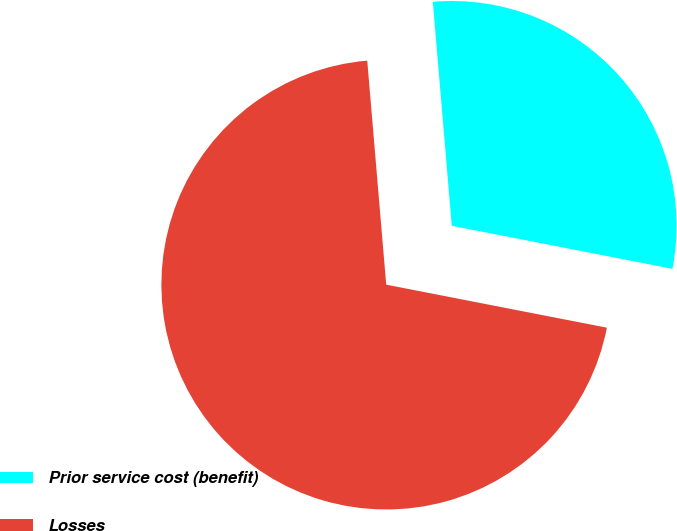Convert chart to OTSL. <chart><loc_0><loc_0><loc_500><loc_500><pie_chart><fcel>Prior service cost (benefit)<fcel>Losses<nl><fcel>29.41%<fcel>70.59%<nl></chart> 